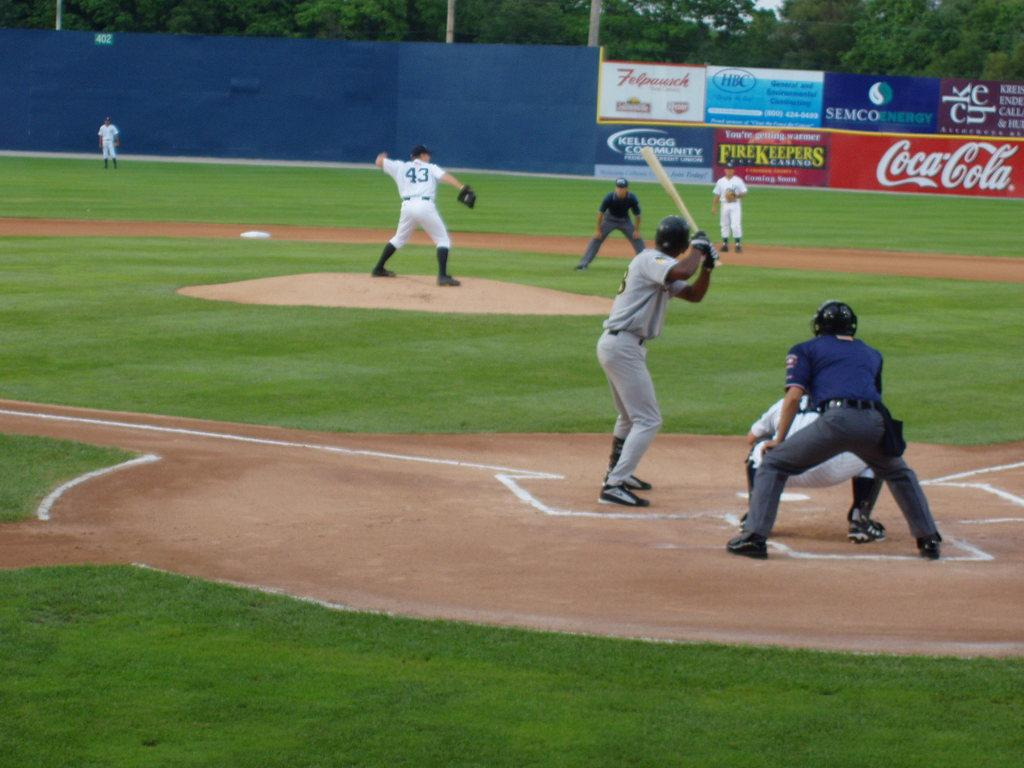Provide a one-sentence caption for the provided image. Coca Cola advertises at this minor league stadium. 